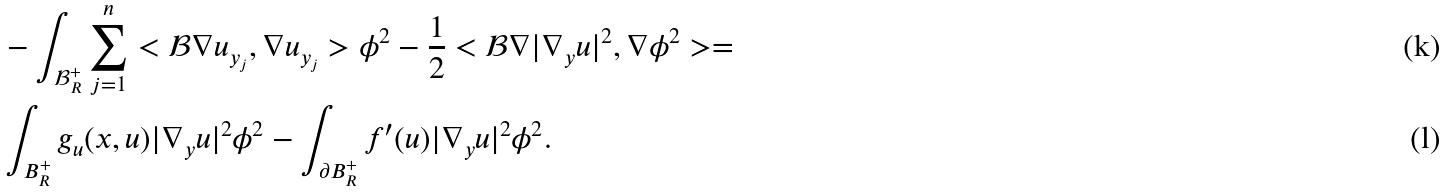<formula> <loc_0><loc_0><loc_500><loc_500>& - \int _ { \mathcal { B } _ { R } ^ { + } } \sum _ { j = 1 } ^ { n } < \mathcal { B } \nabla u _ { y _ { j } } , \nabla u _ { y _ { j } } > \phi ^ { 2 } - \frac { 1 } { 2 } < \mathcal { B } \nabla | \nabla _ { y } u | ^ { 2 } , \nabla \phi ^ { 2 } > = \\ & \int _ { B _ { R } ^ { + } } g _ { u } ( x , u ) | \nabla _ { y } u | ^ { 2 } \phi ^ { 2 } - \int _ { \partial B _ { R } ^ { + } } f ^ { \prime } ( u ) | \nabla _ { y } u | ^ { 2 } \phi ^ { 2 } .</formula> 